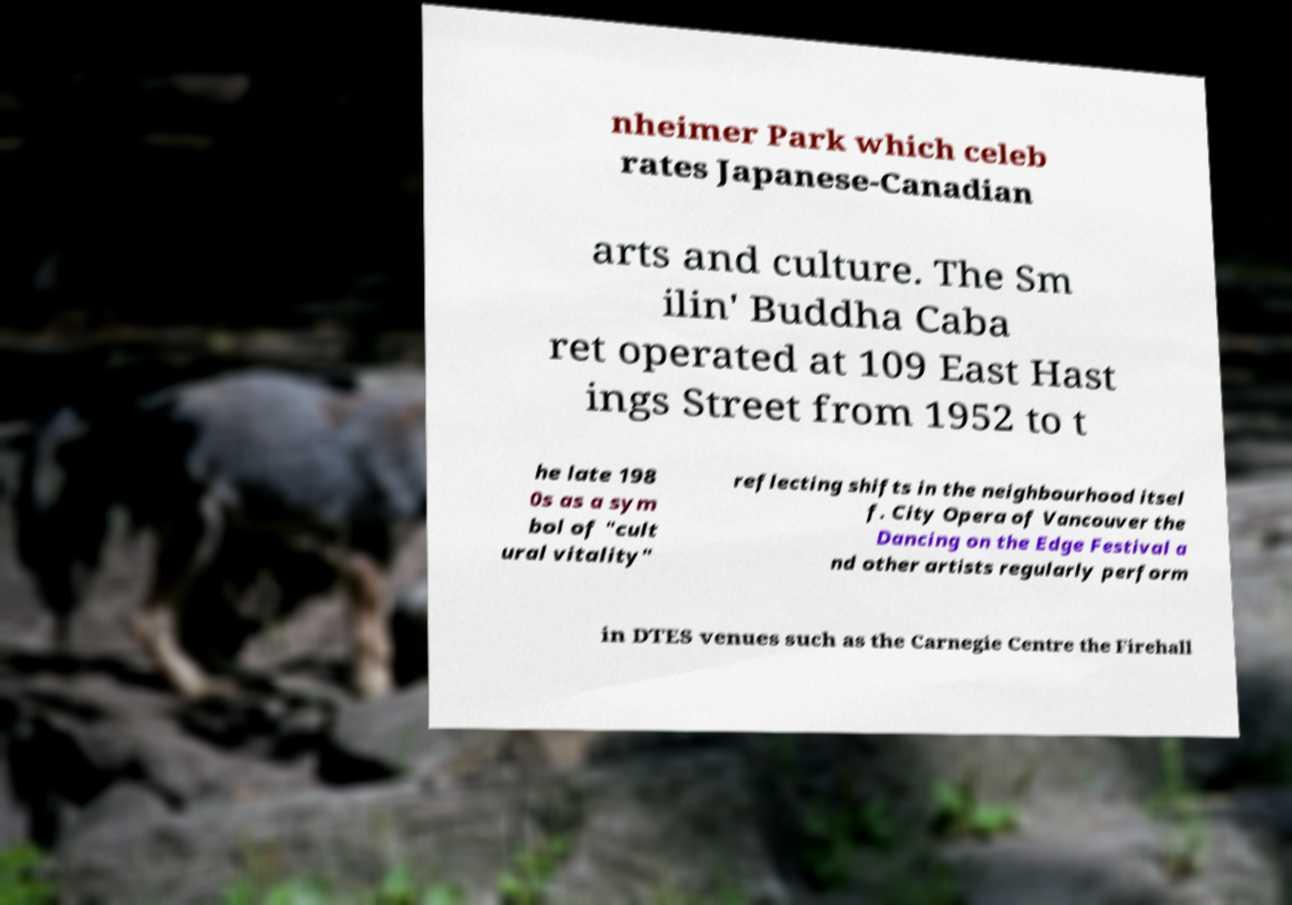Can you read and provide the text displayed in the image?This photo seems to have some interesting text. Can you extract and type it out for me? nheimer Park which celeb rates Japanese-Canadian arts and culture. The Sm ilin' Buddha Caba ret operated at 109 East Hast ings Street from 1952 to t he late 198 0s as a sym bol of "cult ural vitality" reflecting shifts in the neighbourhood itsel f. City Opera of Vancouver the Dancing on the Edge Festival a nd other artists regularly perform in DTES venues such as the Carnegie Centre the Firehall 